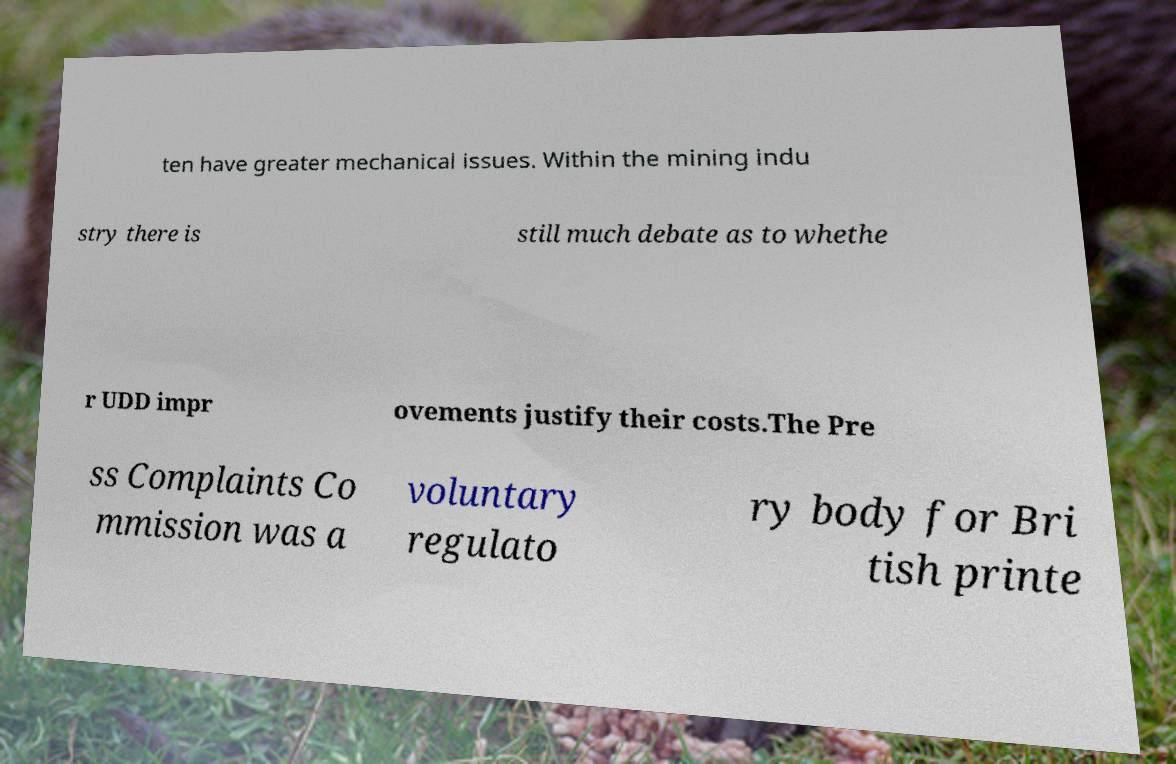Could you assist in decoding the text presented in this image and type it out clearly? ten have greater mechanical issues. Within the mining indu stry there is still much debate as to whethe r UDD impr ovements justify their costs.The Pre ss Complaints Co mmission was a voluntary regulato ry body for Bri tish printe 